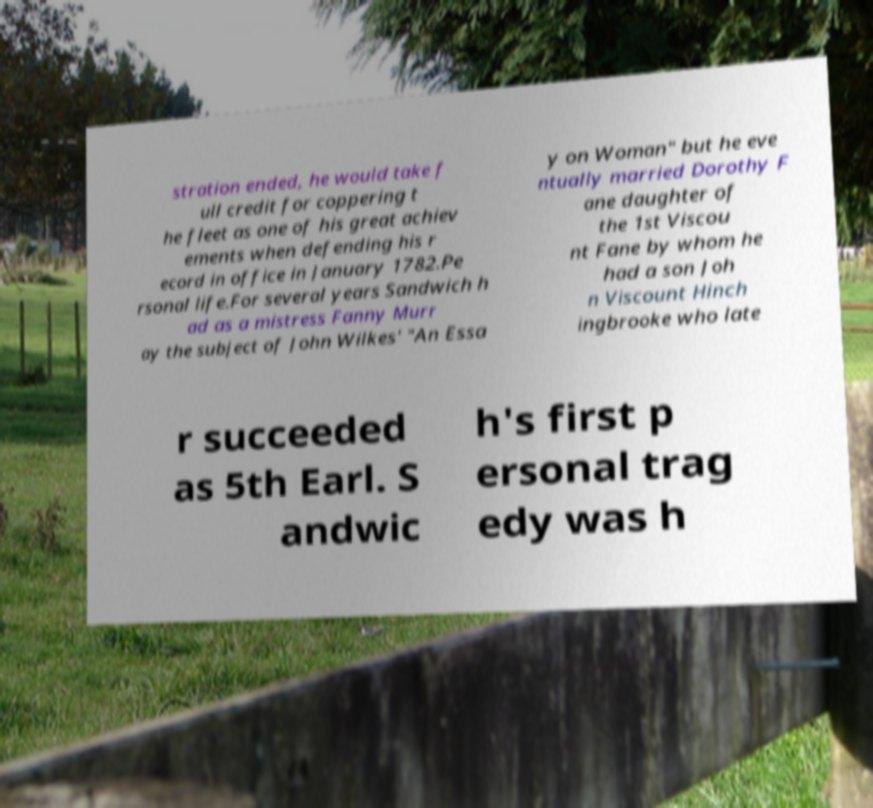Please read and relay the text visible in this image. What does it say? stration ended, he would take f ull credit for coppering t he fleet as one of his great achiev ements when defending his r ecord in office in January 1782.Pe rsonal life.For several years Sandwich h ad as a mistress Fanny Murr ay the subject of John Wilkes' "An Essa y on Woman" but he eve ntually married Dorothy F ane daughter of the 1st Viscou nt Fane by whom he had a son Joh n Viscount Hinch ingbrooke who late r succeeded as 5th Earl. S andwic h's first p ersonal trag edy was h 